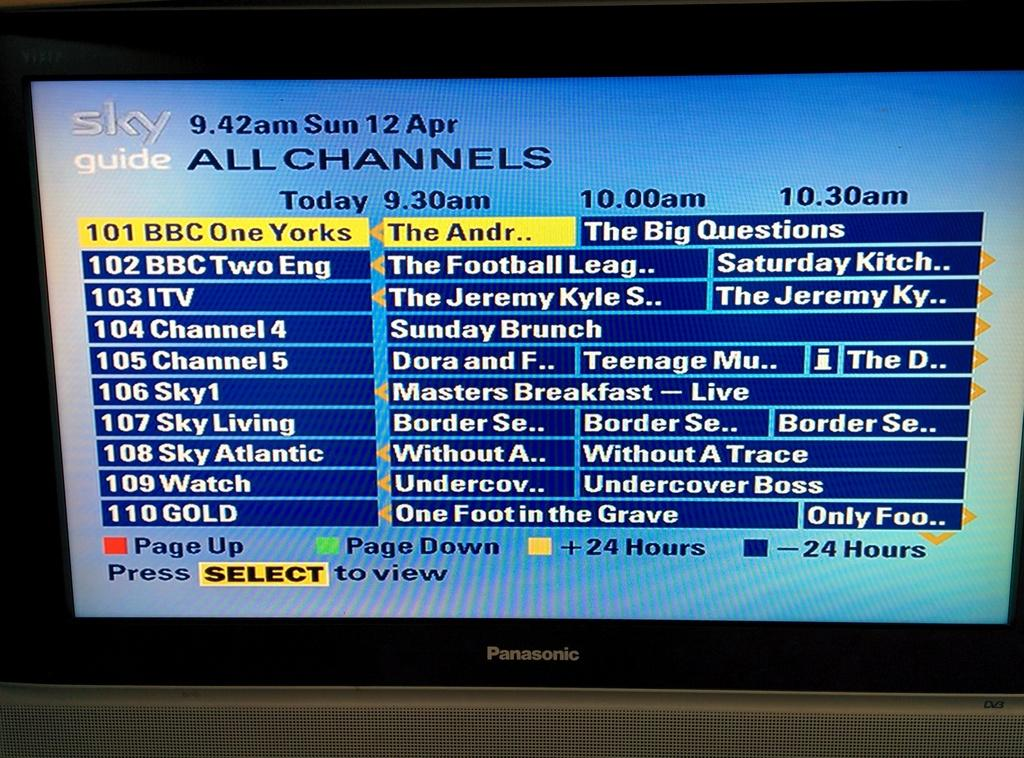<image>
Give a short and clear explanation of the subsequent image. The TV Guide menu currently has channel 101 selected. 